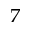<formula> <loc_0><loc_0><loc_500><loc_500>^ { 7 }</formula> 